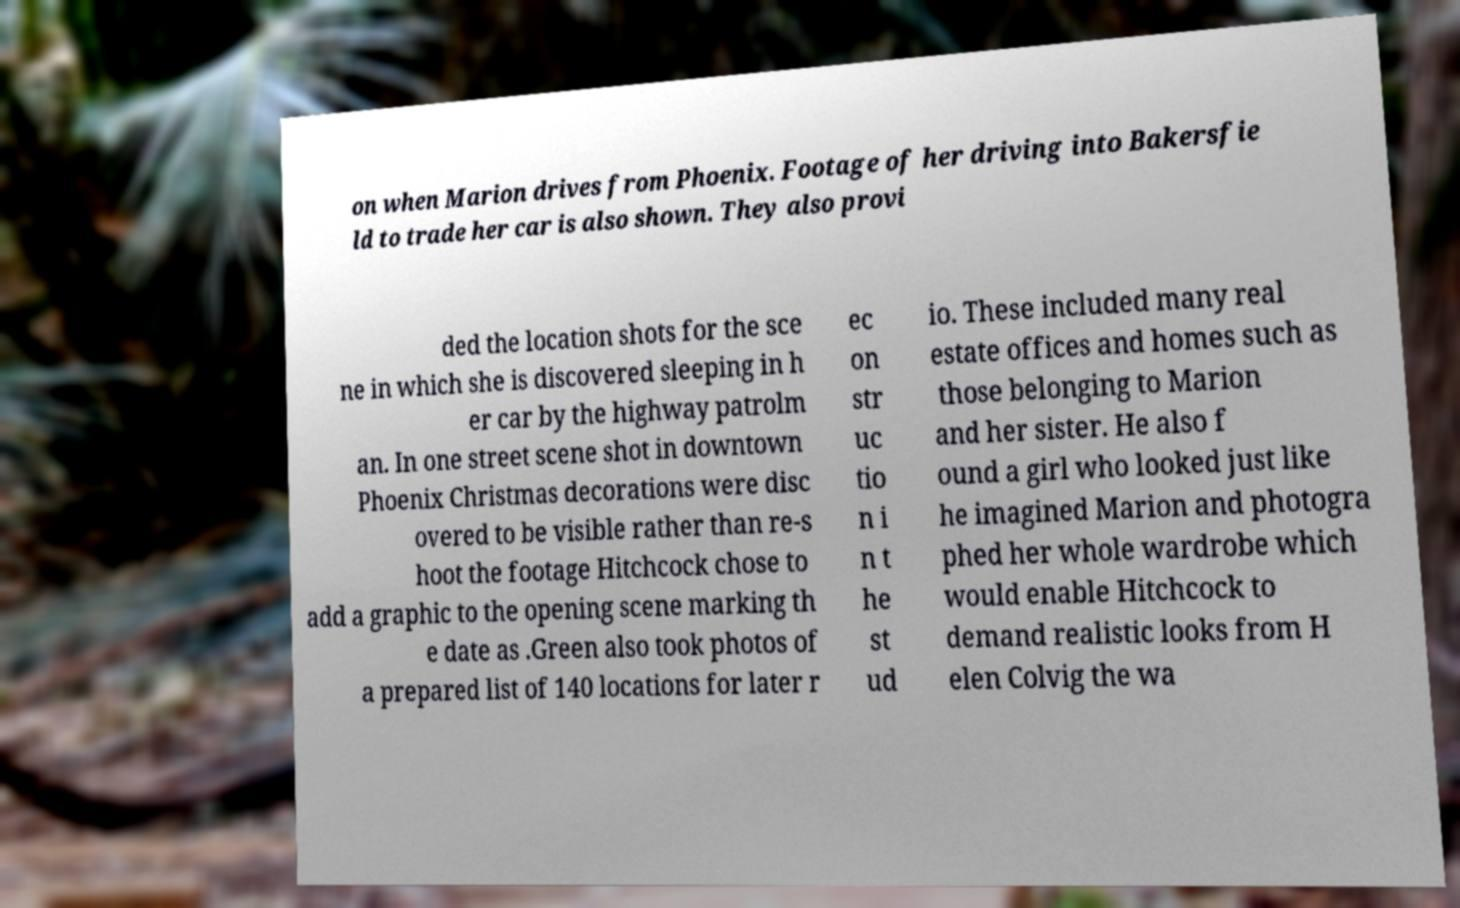Please read and relay the text visible in this image. What does it say? on when Marion drives from Phoenix. Footage of her driving into Bakersfie ld to trade her car is also shown. They also provi ded the location shots for the sce ne in which she is discovered sleeping in h er car by the highway patrolm an. In one street scene shot in downtown Phoenix Christmas decorations were disc overed to be visible rather than re-s hoot the footage Hitchcock chose to add a graphic to the opening scene marking th e date as .Green also took photos of a prepared list of 140 locations for later r ec on str uc tio n i n t he st ud io. These included many real estate offices and homes such as those belonging to Marion and her sister. He also f ound a girl who looked just like he imagined Marion and photogra phed her whole wardrobe which would enable Hitchcock to demand realistic looks from H elen Colvig the wa 